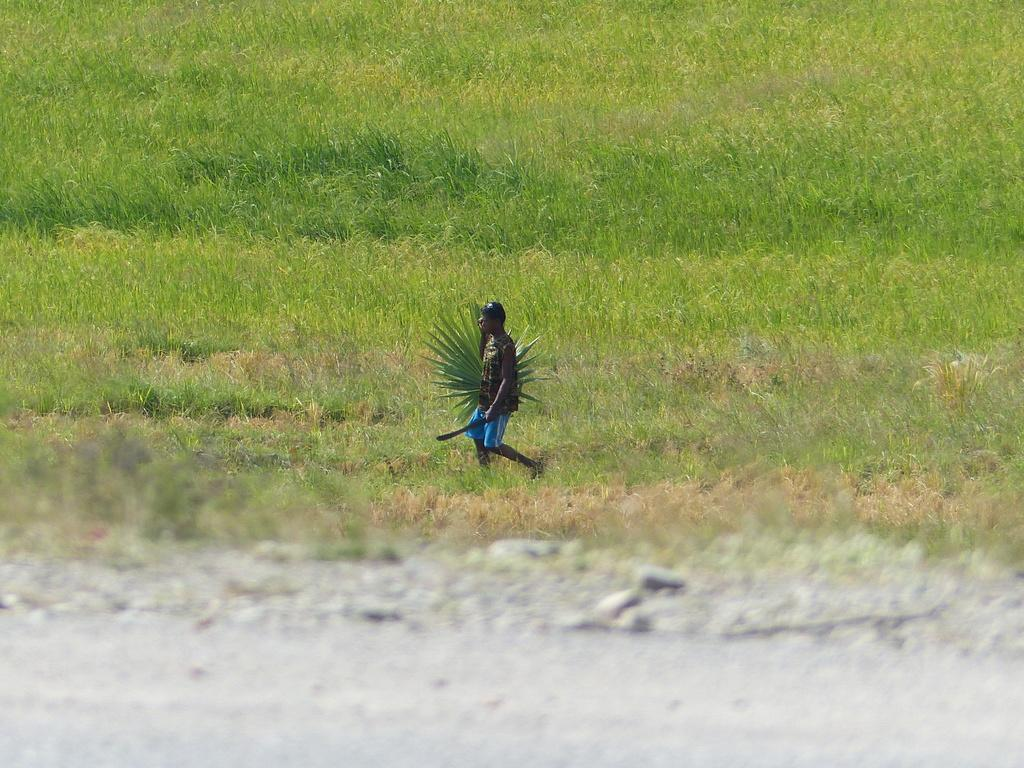Who is the main subject in the image? There is a man in the center of the image. What is the man holding in the image? The man is holding a green object. What is the man doing in the image? The man is walking. What type of terrain can be seen in the background of the image? There is grass on the ground in the background of the image. What type of scarf is the man wearing in the image? The man is not wearing a scarf in the image. What error can be seen in the image? There is no error present in the image. 